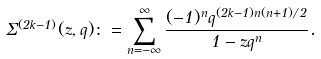<formula> <loc_0><loc_0><loc_500><loc_500>\Sigma ^ { ( 2 k - 1 ) } ( z , q ) \colon = \sum _ { n = - \infty } ^ { \infty } \frac { ( - 1 ) ^ { n } q ^ { ( 2 k - 1 ) n ( n + 1 ) / 2 } } { 1 - z q ^ { n } } .</formula> 